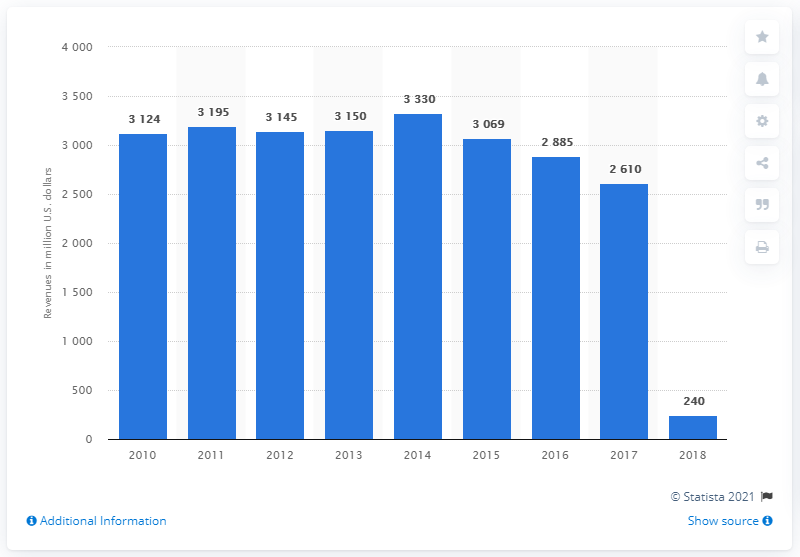Indicate a few pertinent items in this graphic. In 2018, McKesson's Technology Solutions generated approximately $240 million in revenue. 